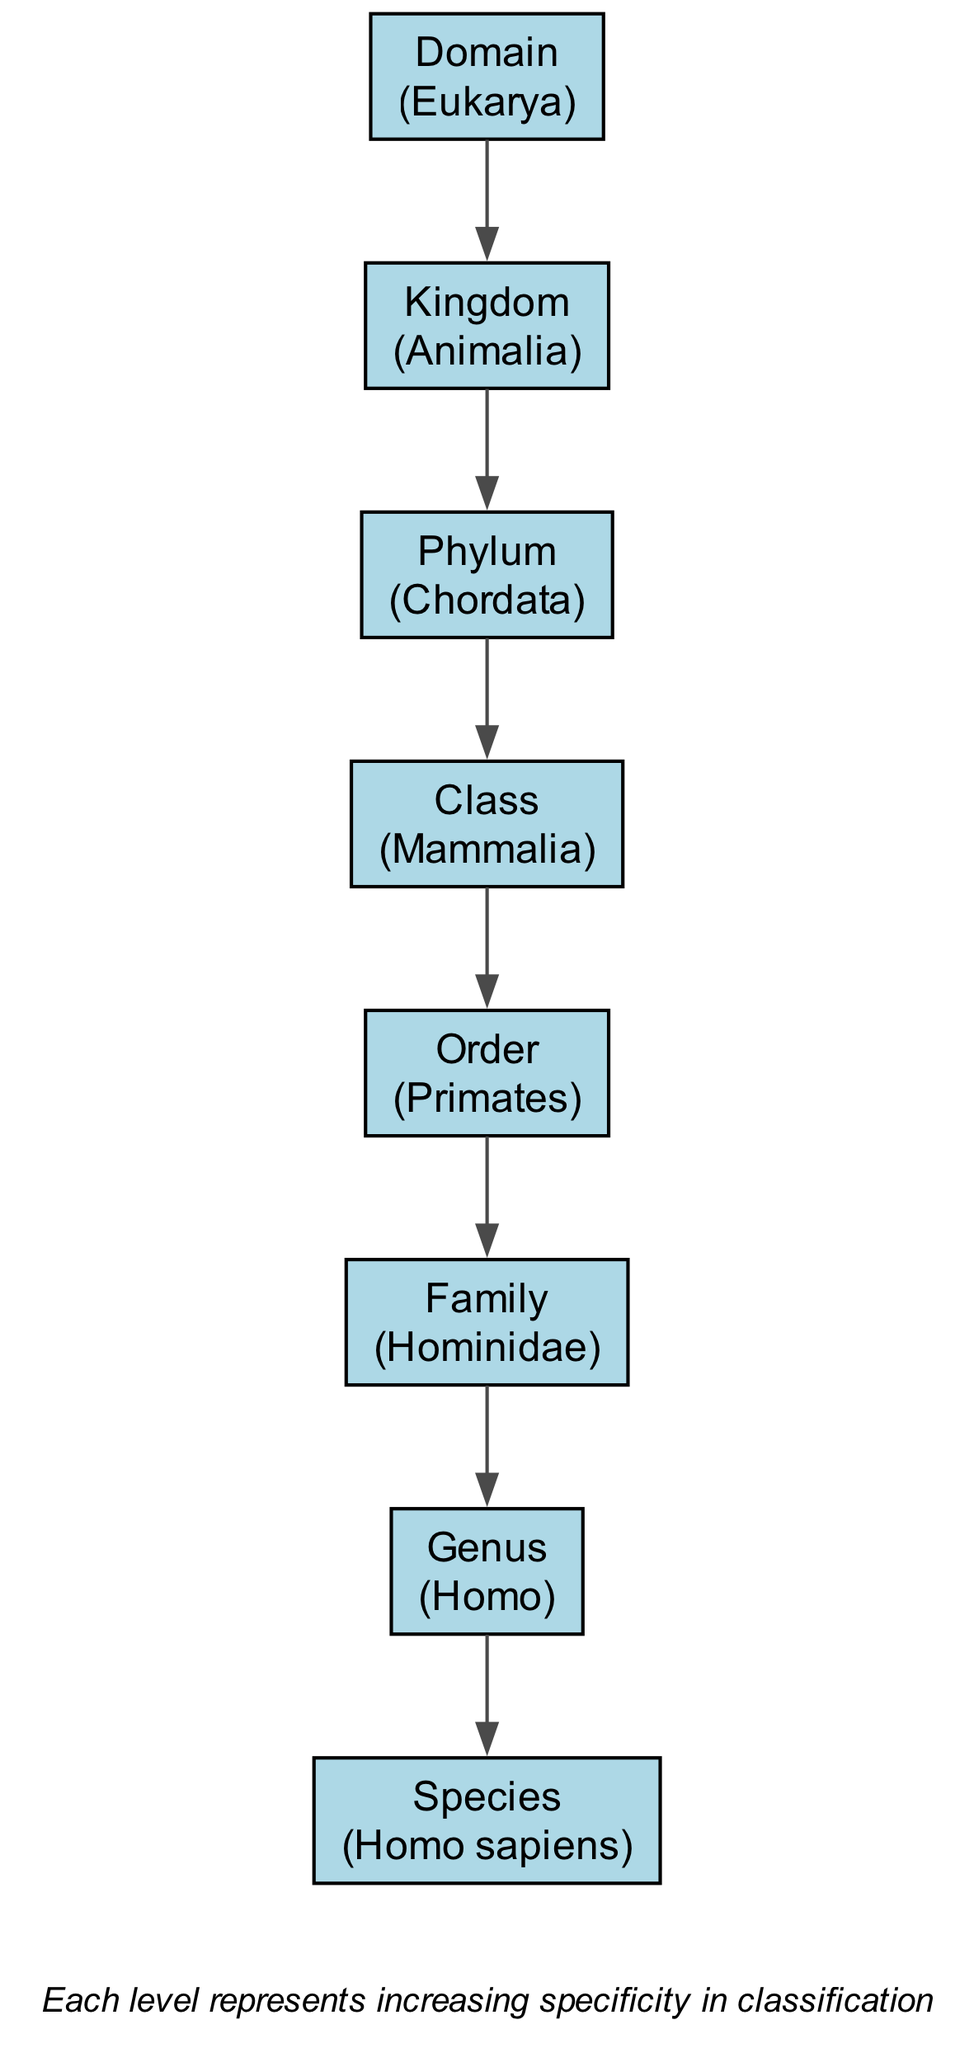What is the highest taxonomic rank in the diagram? The highest taxonomic rank is "Domain," which is located at the top of the hierarchical structure in the diagram.
Answer: Domain What example is provided for the Kingdom level? The example provided for the Kingdom level is "Animalia," which is listed directly under the Kingdom node in the diagram.
Answer: Animalia How many nodes are present in the diagram? There are eight nodes present in the diagram, each representing a different taxonomic rank from Domain to Species.
Answer: 8 What is the relationship between Phylum and Class? The relationship shows that the Phylum node leads to the Class node, meaning that Class is a more specific classification that falls under Phylum.
Answer: Phylum to Class Which example is given for the Genus level? The example given for the Genus level is "Homo," which is shown in the diagram under the Genus node.
Answer: Homo Which taxonomic rank is one level below Order? The taxonomic rank one level below Order in the hierarchy is "Family," as indicated by the downward connection in the diagram.
Answer: Family What type of diagram is represented? The diagram represents a hierarchical structure illustrating the classification of living organisms, showing the organization from broad categories to specific entities.
Answer: Hierarchical Explain the connection between Family and Species. The Family node connects downward to the Genus node, and then Genus connects to Species, meaning that Species is the most specific classification that is categorized under the Genus, which is contained within the Family.
Answer: Family to Species 